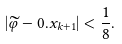<formula> <loc_0><loc_0><loc_500><loc_500>| \widetilde { \varphi } - 0 . x _ { k + 1 } | < \frac { 1 } { 8 } .</formula> 